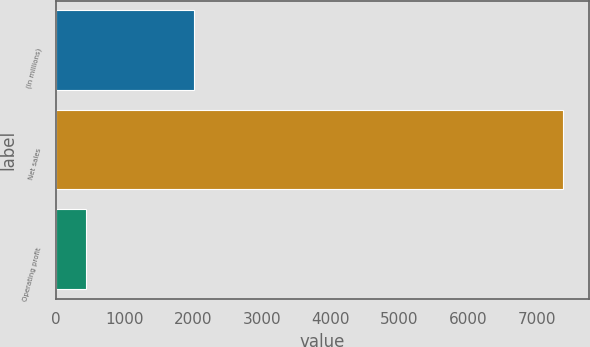Convert chart to OTSL. <chart><loc_0><loc_0><loc_500><loc_500><bar_chart><fcel>(In millions)<fcel>Net sales<fcel>Operating profit<nl><fcel>2002<fcel>7384<fcel>443<nl></chart> 